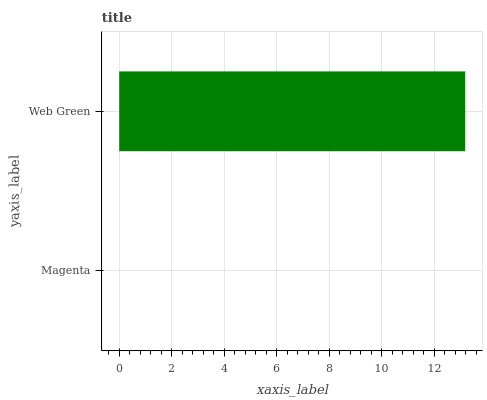Is Magenta the minimum?
Answer yes or no. Yes. Is Web Green the maximum?
Answer yes or no. Yes. Is Web Green the minimum?
Answer yes or no. No. Is Web Green greater than Magenta?
Answer yes or no. Yes. Is Magenta less than Web Green?
Answer yes or no. Yes. Is Magenta greater than Web Green?
Answer yes or no. No. Is Web Green less than Magenta?
Answer yes or no. No. Is Web Green the high median?
Answer yes or no. Yes. Is Magenta the low median?
Answer yes or no. Yes. Is Magenta the high median?
Answer yes or no. No. Is Web Green the low median?
Answer yes or no. No. 